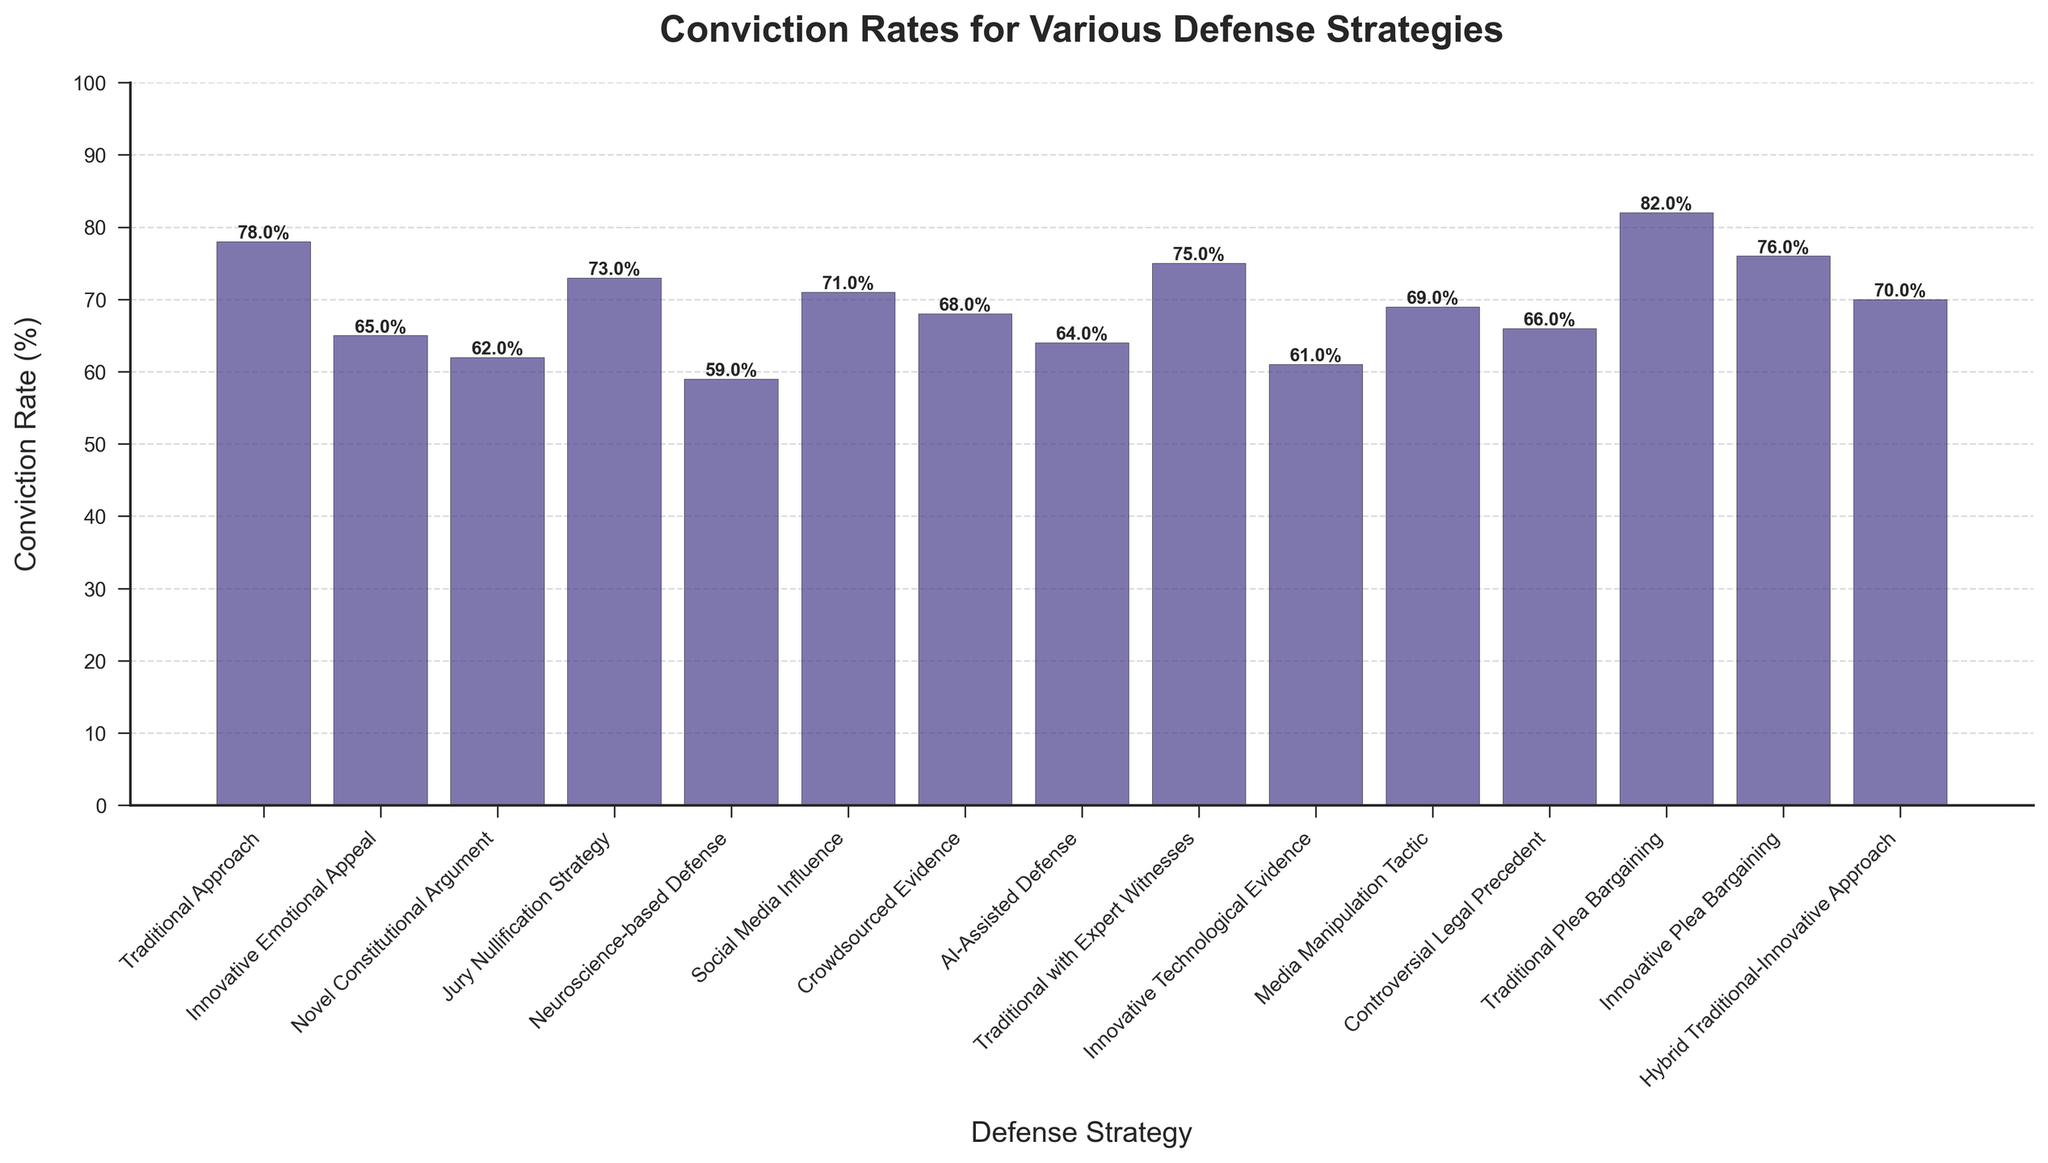Which defense strategy has the highest conviction rate? By looking at the heights of the bars, the defense strategy with the highest bar represents the highest conviction rate.
Answer: Traditional Plea Bargaining Which defense strategy has the lowest conviction rate? By examining the heights of the bars, the defense strategy with the shortest bar represents the lowest conviction rate.
Answer: Neuroscience-based Defense How many defense strategies have a conviction rate above 70%? Count the bars that exceed the 70% mark along the y-axis. The bars for Traditional Approach (78%), Jury Nullification Strategy (73%), Social Media Influence (71%), Traditional Plea Bargaining (82%), and Innovative Plea Bargaining (76%) all qualify.
Answer: 5 What is the conviction rate difference between the Traditional Approach and the Innovative Technological Evidence strategy? Find the heights of the bars for both strategies, subtract the conviction rate of Innovative Technological Evidence (61%) from Traditional Approach (78%).
Answer: 17% Which strategy among Innovative Emotional Appeal and AI-Assisted Defense has a lower conviction rate? Compare the heights of the bars for Innovative Emotional Appeal (65%) and AI-Assisted Defense (64%). The bar for AI-Assisted Defense is slightly shorter.
Answer: AI-Assisted Defense What is the average conviction rate across all listed defense strategies? Add up all the conviction rates listed and divide by the number of defense strategies. 
\[ \text{(78 + 65 + 62 + 73 + 59 + 71 + 68 + 64 + 75 + 61 + 69 + 66 + 82 + 76 + 70) / 15} \approx 692 / 15 = 69.6 \]
Answer: 69.6% What is the conviction rate difference between using Traditional Approach and Traditional with Expert Witnesses? Find the heights of the bars for both strategies, subtract the conviction rate of Traditional with Expert Witnesses (75%) from Traditional Approach (78%).
Answer: 3% How many strategies have a conviction rate between 60% and 70% inclusive? Count the bars that fall within the range of 60% to 70%. The bars for Innovative Emotional Appeal (65%), Novel Constitutional Argument (62%), Crowdsourced Evidence (68%), AI-Assisted Defense (64%), Innovative Technological Evidence (61%), Media Manipulation Tactic (69%), and Controversial Legal Precedent (66%) qualify.
Answer: 7 Compare the conviction rates of Social Media Influence and Media Manipulation Tactic. Which one is higher, and by how much? Find the heights of the bars for Social Media Influence (71%) and Media Manipulation Tactic (69%). Subtract the Media Manipulation Tactic rate from the Social Media Influence rate.
Answer: Social Media Influence, 2% Out of the Innovative strategies, which one has the highest conviction rate? Identify all innovative strategies and compare the heights of their bars. Innovative Emotional Appeal (65%), Novel Constitutional Argument (62%), Jury Nullification Strategy (73%), Neuroscience-based Defense (59%), Social Media Influence (71%), Crowdsourced Evidence (68%), AI-Assisted Defense (64%), Innovative Technological Evidence (61%), Media Manipulation Tactic (69%), Innovative Plea Bargaining (76%), Controversial Legal Precedent (66%). Innovative Plea Bargaining has the highest conviction rate of these strategies.
Answer: Innovative Plea Bargaining 